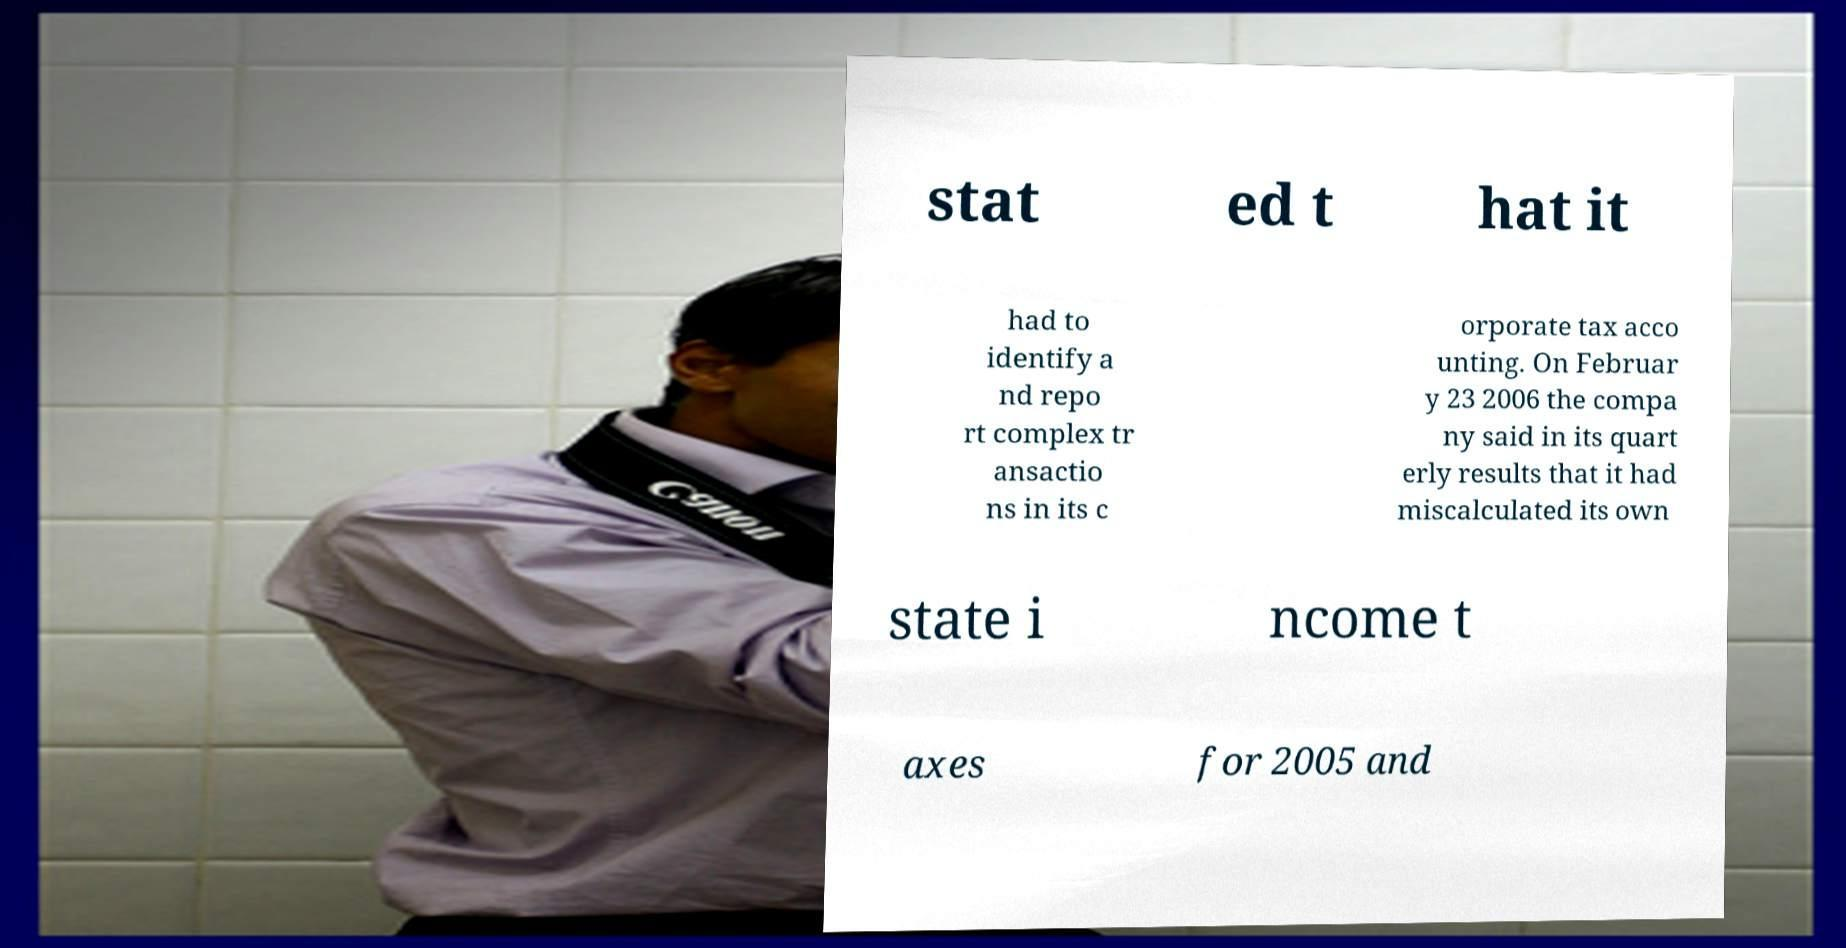I need the written content from this picture converted into text. Can you do that? stat ed t hat it had to identify a nd repo rt complex tr ansactio ns in its c orporate tax acco unting. On Februar y 23 2006 the compa ny said in its quart erly results that it had miscalculated its own state i ncome t axes for 2005 and 